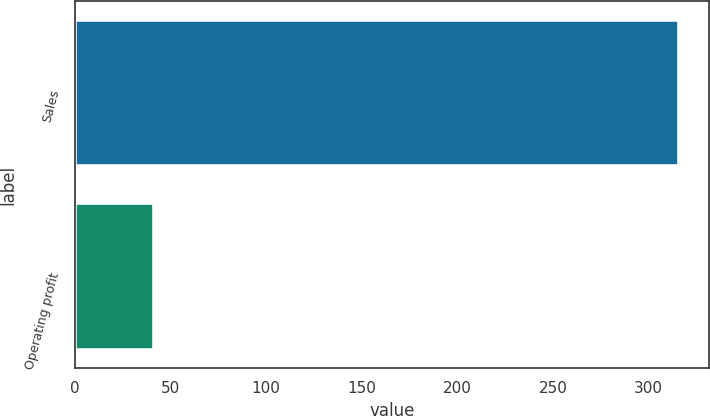<chart> <loc_0><loc_0><loc_500><loc_500><bar_chart><fcel>Sales<fcel>Operating profit<nl><fcel>315.6<fcel>41.5<nl></chart> 